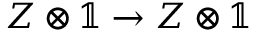Convert formula to latex. <formula><loc_0><loc_0><loc_500><loc_500>Z \otimes \mathbb { 1 } \to Z \otimes \mathbb { 1 }</formula> 